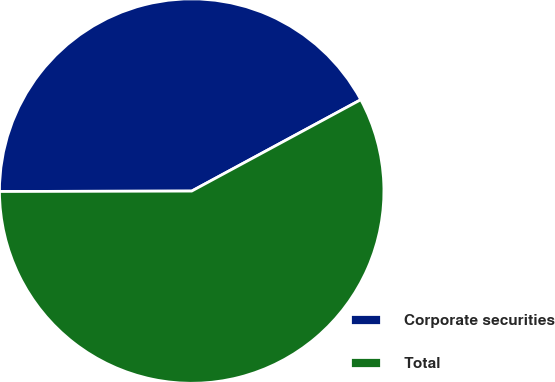<chart> <loc_0><loc_0><loc_500><loc_500><pie_chart><fcel>Corporate securities<fcel>Total<nl><fcel>42.15%<fcel>57.85%<nl></chart> 